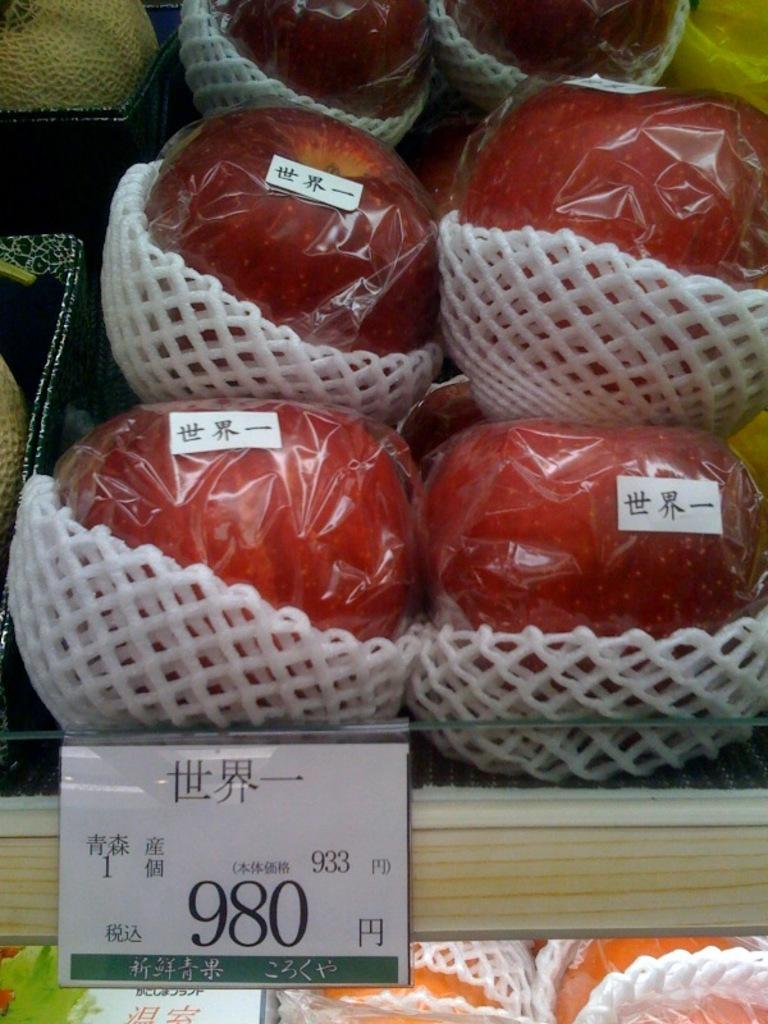What types of fruits are visible in the image? There are apples, muskmelons, and oranges visible in the image. How are the fruits arranged or displayed in the image? The fruits are placed on wooden racks in the image. Is there any additional information about the fruits or their arrangement? Yes, there is a price board in the image. What type of belief is represented by the grapes in the image? There are no grapes present in the image, so it is not possible to determine what belief might be represented by them. Can you see any cracks in the fruits in the image? The provided facts do not mention any cracks in the fruits, so it cannot be determined from the image. 